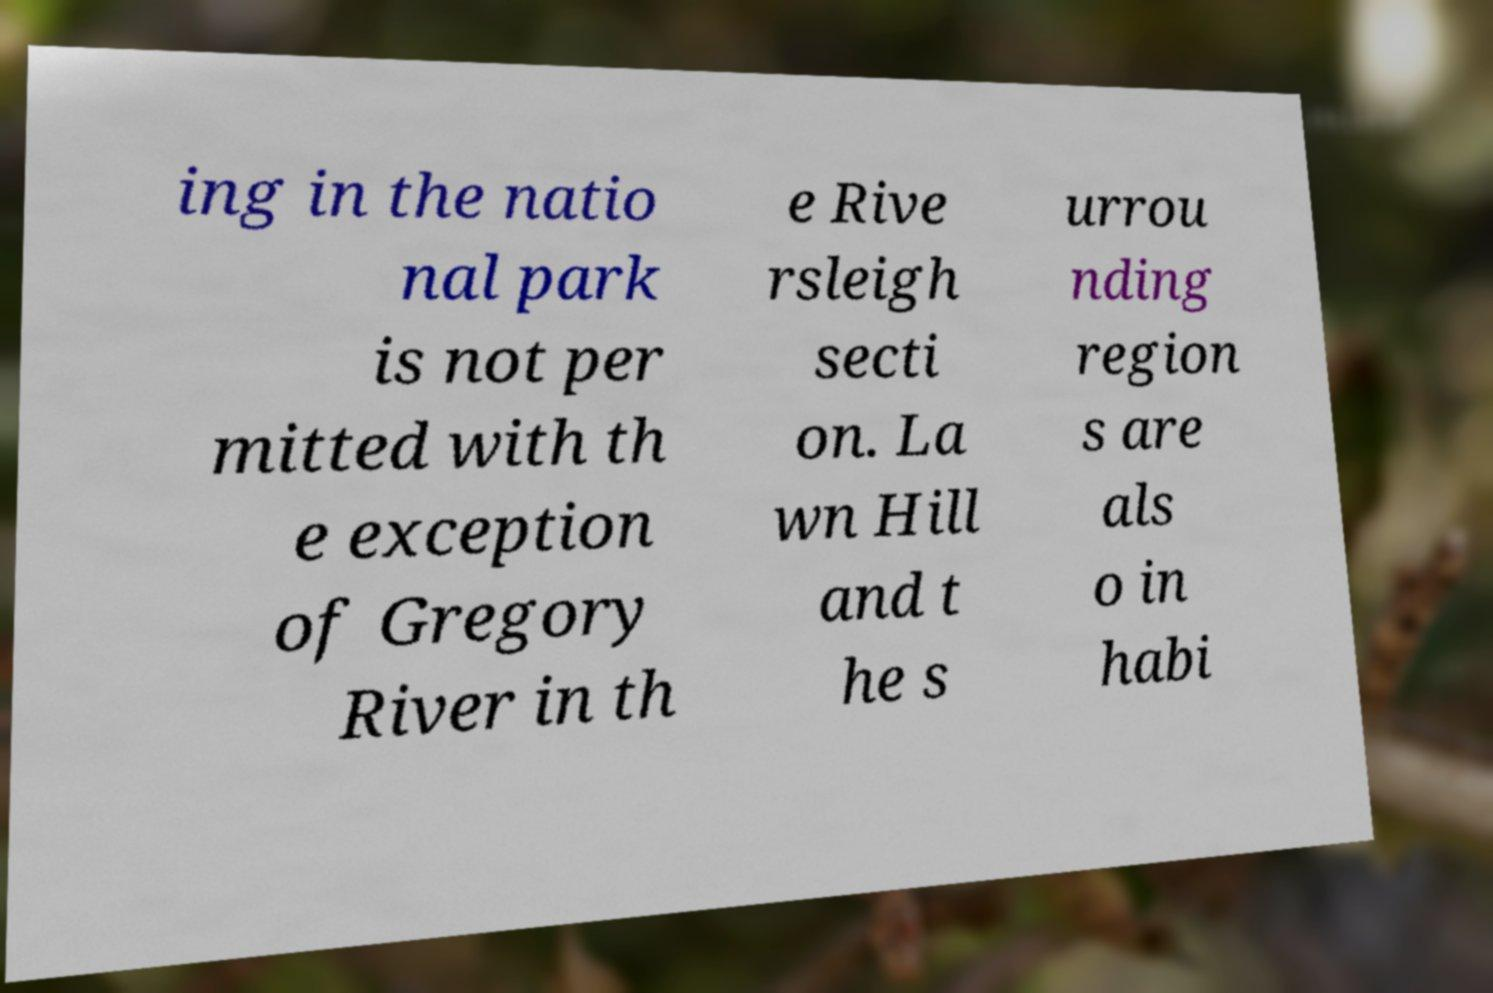What messages or text are displayed in this image? I need them in a readable, typed format. ing in the natio nal park is not per mitted with th e exception of Gregory River in th e Rive rsleigh secti on. La wn Hill and t he s urrou nding region s are als o in habi 